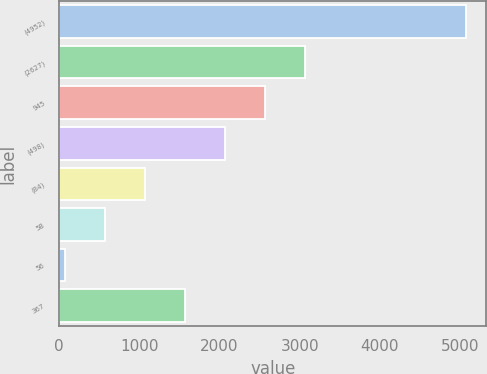Convert chart to OTSL. <chart><loc_0><loc_0><loc_500><loc_500><bar_chart><fcel>(4952)<fcel>(2627)<fcel>945<fcel>(498)<fcel>(84)<fcel>58<fcel>56<fcel>367<nl><fcel>5074<fcel>3071.6<fcel>2571<fcel>2070.4<fcel>1069.2<fcel>568.6<fcel>68<fcel>1569.8<nl></chart> 